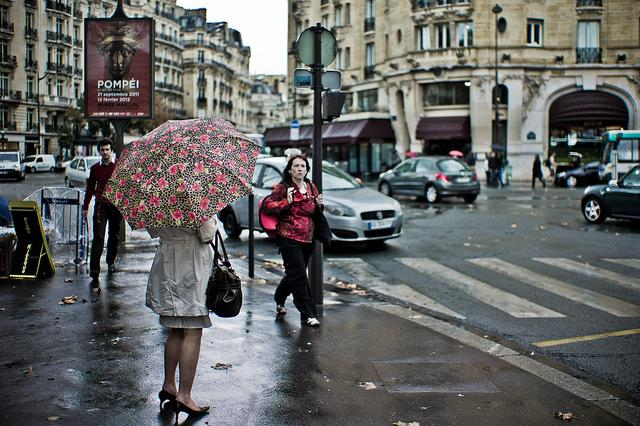When does the Pompeii exhibit end? Please explain your reasoning. 2012. The start and end dates are on the sign that is above the person with the umbrella. 